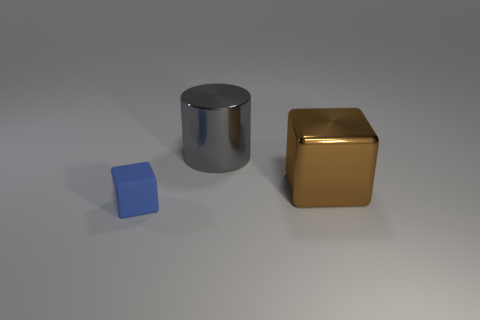Add 2 small gray metallic blocks. How many objects exist? 5 Add 3 small blue rubber blocks. How many small blue rubber blocks exist? 4 Subtract 1 brown blocks. How many objects are left? 2 Subtract all cylinders. How many objects are left? 2 Subtract all green cylinders. Subtract all gray spheres. How many cylinders are left? 1 Subtract all rubber cubes. Subtract all cylinders. How many objects are left? 1 Add 1 metallic objects. How many metallic objects are left? 3 